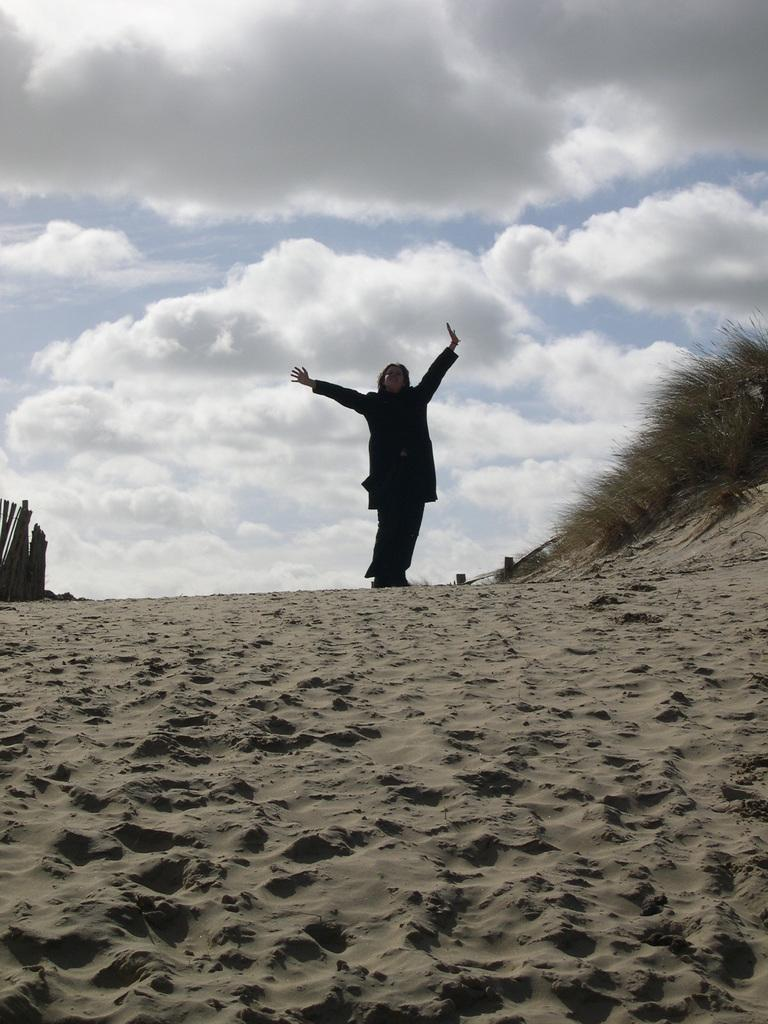What is the main subject of the image? There is a person standing in the image. What is the person standing on? The person is standing on a surface that appears to be sand. What can be seen in the sky in the image? There are clouds visible in the sky. How many fans are visible in the image? There are no fans present in the image. What type of brothers can be seen playing in the sand in the image? There are no brothers or any indication of playing in the image; it only features a person standing on sand. 